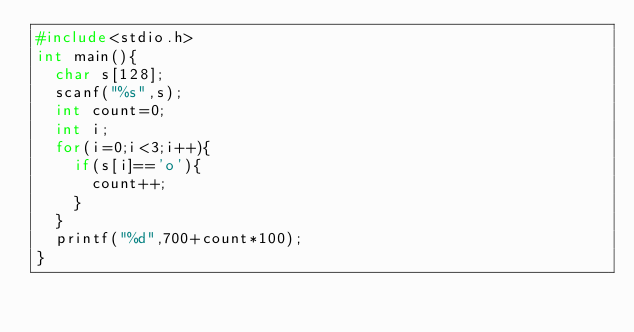Convert code to text. <code><loc_0><loc_0><loc_500><loc_500><_C_>#include<stdio.h>
int main(){
  char s[128];
  scanf("%s",s);
  int count=0;
  int i;
  for(i=0;i<3;i++){
    if(s[i]=='o'){
      count++;
    }
  }
  printf("%d",700+count*100);
}

</code> 